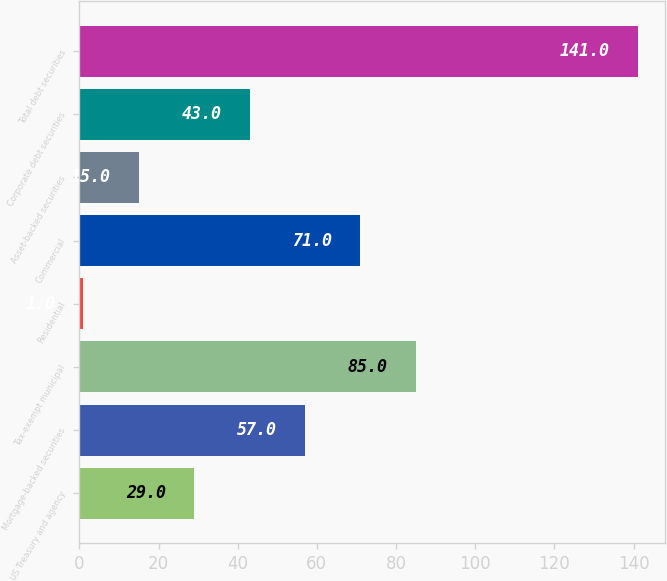<chart> <loc_0><loc_0><loc_500><loc_500><bar_chart><fcel>US Treasury and agency<fcel>Mortgage-backed securities<fcel>Tax-exempt municipal<fcel>Residential<fcel>Commercial<fcel>Asset-backed securities<fcel>Corporate debt securities<fcel>Total debt securities<nl><fcel>29<fcel>57<fcel>85<fcel>1<fcel>71<fcel>15<fcel>43<fcel>141<nl></chart> 